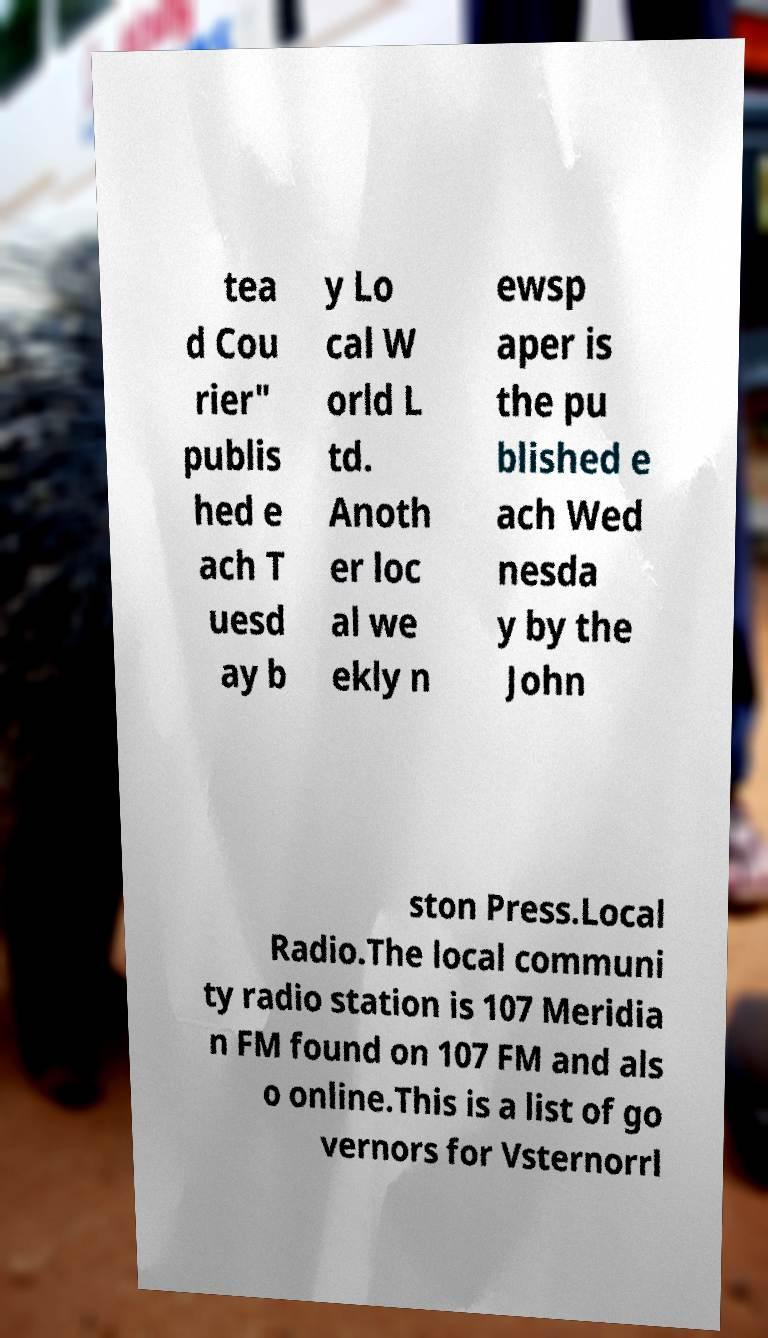For documentation purposes, I need the text within this image transcribed. Could you provide that? tea d Cou rier" publis hed e ach T uesd ay b y Lo cal W orld L td. Anoth er loc al we ekly n ewsp aper is the pu blished e ach Wed nesda y by the John ston Press.Local Radio.The local communi ty radio station is 107 Meridia n FM found on 107 FM and als o online.This is a list of go vernors for Vsternorrl 